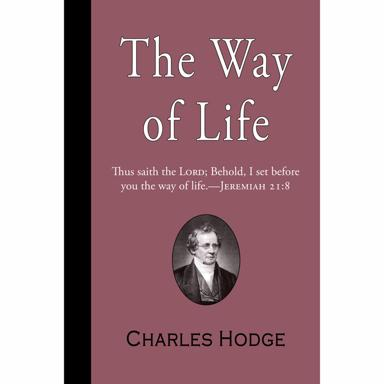Who is Charles Hodge? Charles Hodge was a distinguished 19th-century American theologian, profoundly influential in the Presbyterian church. He served as the principal of Princeton Theological Seminary for nearly three decades, from 1851 to 1878. Hodge was a central figure in American religious academia, known for his orthodox teachings and extensive writings, which shaped the Calvinist tradition in America and continue to influence Christian theology today. 